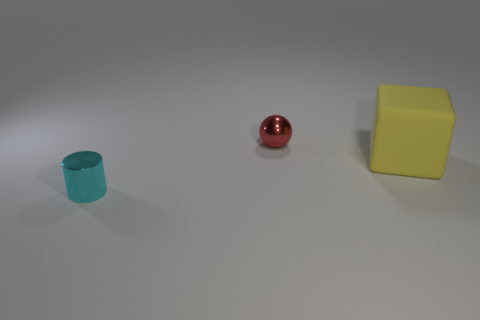What can you infer about the lighting in this scene? The lighting in this scene seems to be diffused with no harsh shadows, indicating either a soft overhead light or ambient light in a room. The soft reflection and the lack of sharp shadows on the objects suggest the light source isn't very close to the objects. 